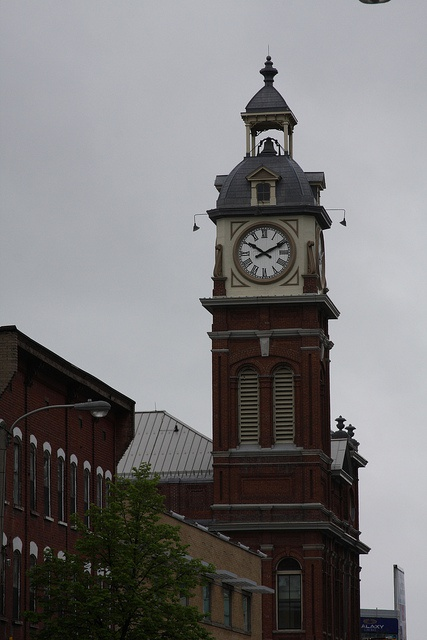Describe the objects in this image and their specific colors. I can see a clock in darkgray, black, and gray tones in this image. 